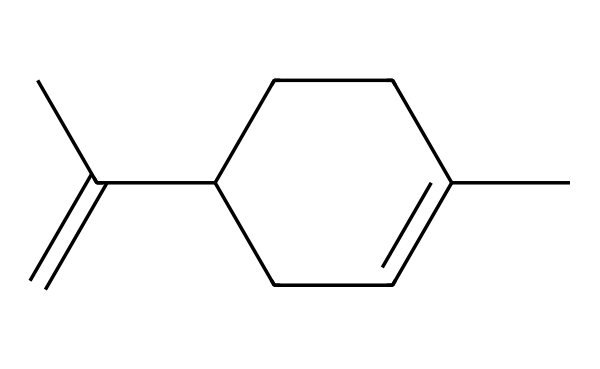What is the molecular formula of limonene? To determine the molecular formula, we analyze the SMILES representation and count each type of atom present. The structure consists of 10 carbon atoms (C) and 16 hydrogen atoms (H). Therefore, the molecular formula is C10H16.
Answer: C10H16 How many chiral centers are present in limonene? A chiral center is typically a carbon atom that is bonded to four different substituents. In the provided structure, there is one carbon that meets this criterion, indicating that limonene has one chiral center.
Answer: one What functional group is primarily responsible for the citrus scent of limonene? Limonene's structure features a double bond (C=C), which is characteristic of alkenes, typically associated with fruity and citrus-like scents. Thus, the presence of this double bond is the functional feature responsible for the citrus fragrance.
Answer: double bond What is the stereochemistry of limonene? The stereochemistry of a chiral compound indicates the spatial arrangement of atoms. For limonene, it has two enantiomers: (R)-limonene and (S)-limonene. The stereochemistry can be identified through the 3D spatial arrangement of the groups around the chiral center.
Answer: enantiomers Is limonene an achiral compound? By definition, an achiral compound lacks chiral centers. Since limonene has one chiral center, it is not achiral, but rather a chiral compound.
Answer: no Which type of isomerism is exhibited by limonene? Limonene exhibits stereoisomerism due to the presence of a chiral center, leading to its existence in two enantiomeric forms. This classification of isomerism arises from differing spatial arrangements of atoms rather than different connectivity.
Answer: stereoisomerism 